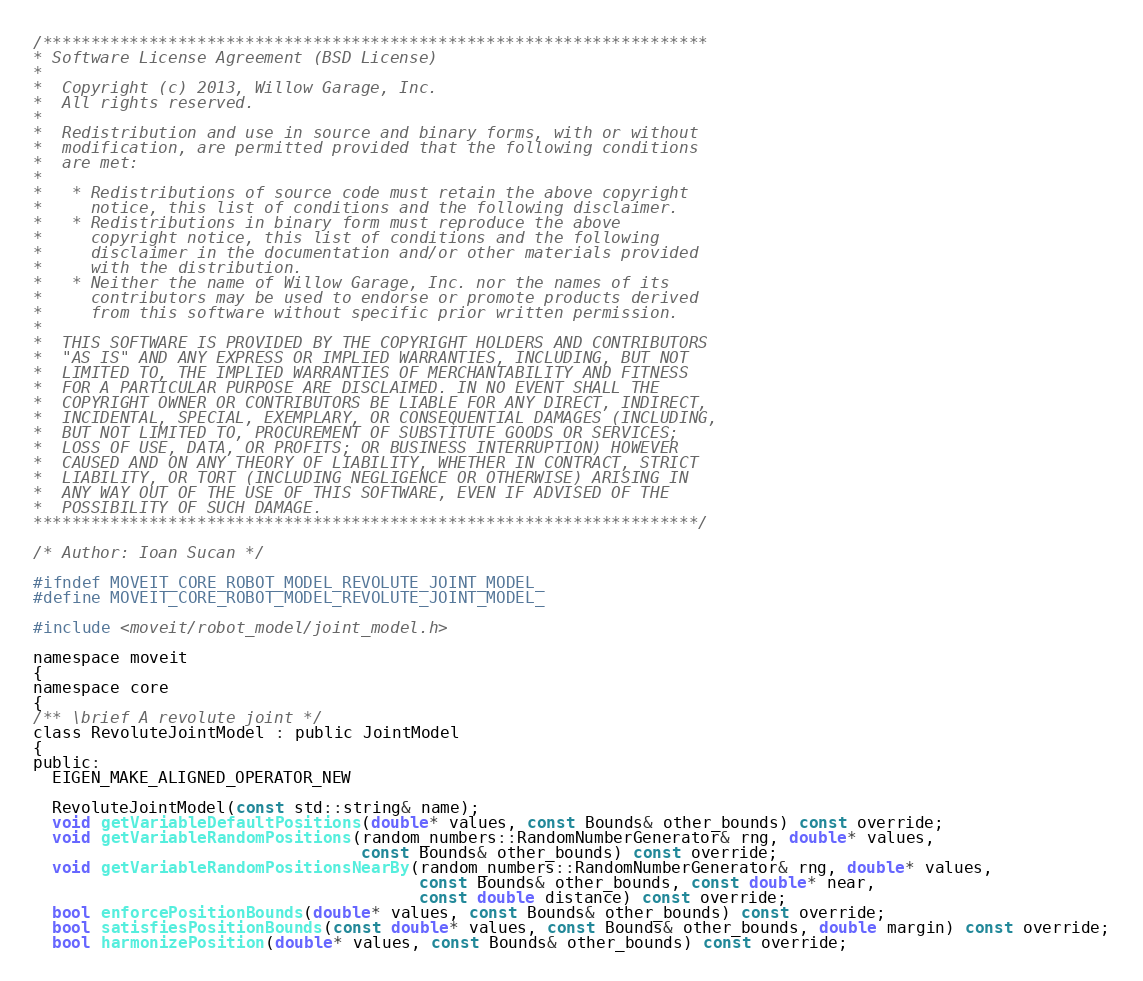Convert code to text. <code><loc_0><loc_0><loc_500><loc_500><_C_>/*********************************************************************
* Software License Agreement (BSD License)
*
*  Copyright (c) 2013, Willow Garage, Inc.
*  All rights reserved.
*
*  Redistribution and use in source and binary forms, with or without
*  modification, are permitted provided that the following conditions
*  are met:
*
*   * Redistributions of source code must retain the above copyright
*     notice, this list of conditions and the following disclaimer.
*   * Redistributions in binary form must reproduce the above
*     copyright notice, this list of conditions and the following
*     disclaimer in the documentation and/or other materials provided
*     with the distribution.
*   * Neither the name of Willow Garage, Inc. nor the names of its
*     contributors may be used to endorse or promote products derived
*     from this software without specific prior written permission.
*
*  THIS SOFTWARE IS PROVIDED BY THE COPYRIGHT HOLDERS AND CONTRIBUTORS
*  "AS IS" AND ANY EXPRESS OR IMPLIED WARRANTIES, INCLUDING, BUT NOT
*  LIMITED TO, THE IMPLIED WARRANTIES OF MERCHANTABILITY AND FITNESS
*  FOR A PARTICULAR PURPOSE ARE DISCLAIMED. IN NO EVENT SHALL THE
*  COPYRIGHT OWNER OR CONTRIBUTORS BE LIABLE FOR ANY DIRECT, INDIRECT,
*  INCIDENTAL, SPECIAL, EXEMPLARY, OR CONSEQUENTIAL DAMAGES (INCLUDING,
*  BUT NOT LIMITED TO, PROCUREMENT OF SUBSTITUTE GOODS OR SERVICES;
*  LOSS OF USE, DATA, OR PROFITS; OR BUSINESS INTERRUPTION) HOWEVER
*  CAUSED AND ON ANY THEORY OF LIABILITY, WHETHER IN CONTRACT, STRICT
*  LIABILITY, OR TORT (INCLUDING NEGLIGENCE OR OTHERWISE) ARISING IN
*  ANY WAY OUT OF THE USE OF THIS SOFTWARE, EVEN IF ADVISED OF THE
*  POSSIBILITY OF SUCH DAMAGE.
*********************************************************************/

/* Author: Ioan Sucan */

#ifndef MOVEIT_CORE_ROBOT_MODEL_REVOLUTE_JOINT_MODEL_
#define MOVEIT_CORE_ROBOT_MODEL_REVOLUTE_JOINT_MODEL_

#include <moveit/robot_model/joint_model.h>

namespace moveit
{
namespace core
{
/** \brief A revolute joint */
class RevoluteJointModel : public JointModel
{
public:
  EIGEN_MAKE_ALIGNED_OPERATOR_NEW

  RevoluteJointModel(const std::string& name);
  void getVariableDefaultPositions(double* values, const Bounds& other_bounds) const override;
  void getVariableRandomPositions(random_numbers::RandomNumberGenerator& rng, double* values,
                                  const Bounds& other_bounds) const override;
  void getVariableRandomPositionsNearBy(random_numbers::RandomNumberGenerator& rng, double* values,
                                        const Bounds& other_bounds, const double* near,
                                        const double distance) const override;
  bool enforcePositionBounds(double* values, const Bounds& other_bounds) const override;
  bool satisfiesPositionBounds(const double* values, const Bounds& other_bounds, double margin) const override;
  bool harmonizePosition(double* values, const Bounds& other_bounds) const override;
</code> 